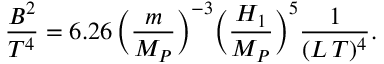Convert formula to latex. <formula><loc_0><loc_0><loc_500><loc_500>\frac { B ^ { 2 } } { T ^ { 4 } } = 6 . 2 6 \, \left ( \frac { m } { M _ { P } } \right ) ^ { - 3 } \left ( \frac { H _ { 1 } } { M _ { P } } \right ) ^ { 5 } \frac { 1 } { ( L \, T ) ^ { 4 } } .</formula> 